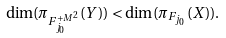<formula> <loc_0><loc_0><loc_500><loc_500>\dim ( \pi _ { F _ { j _ { 0 } } ^ { + M ^ { 2 } } } ( Y ) ) < \dim ( \pi _ { F _ { j _ { 0 } } } ( X ) ) .</formula> 